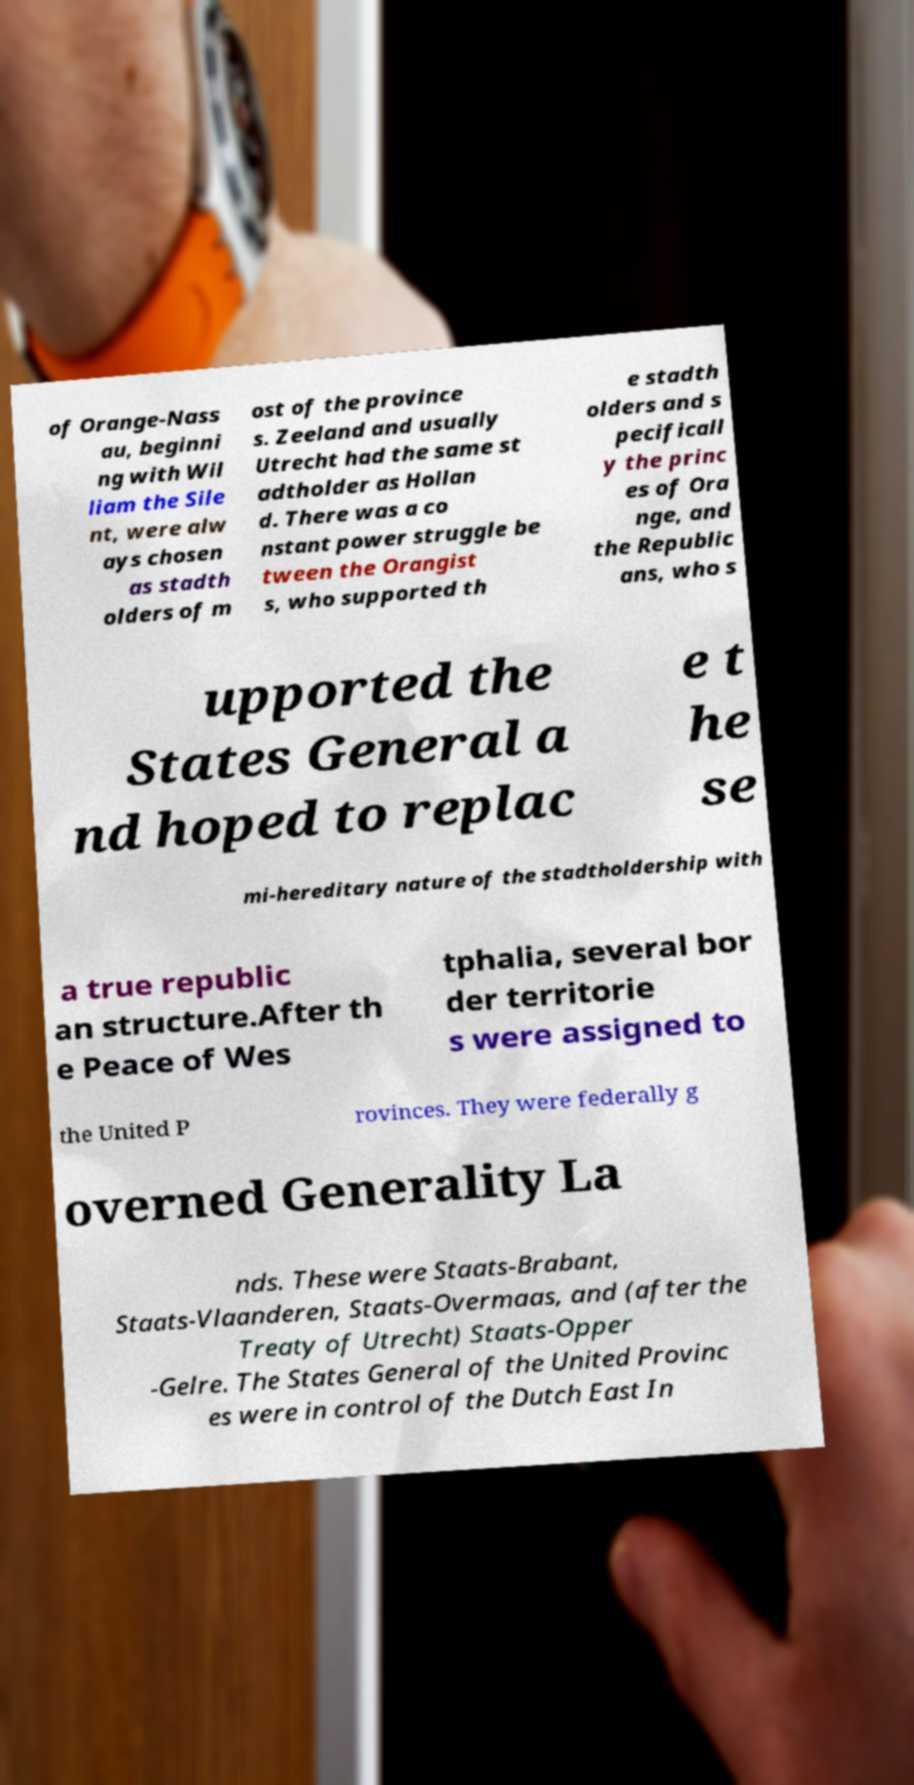Can you read and provide the text displayed in the image?This photo seems to have some interesting text. Can you extract and type it out for me? of Orange-Nass au, beginni ng with Wil liam the Sile nt, were alw ays chosen as stadth olders of m ost of the province s. Zeeland and usually Utrecht had the same st adtholder as Hollan d. There was a co nstant power struggle be tween the Orangist s, who supported th e stadth olders and s pecificall y the princ es of Ora nge, and the Republic ans, who s upported the States General a nd hoped to replac e t he se mi-hereditary nature of the stadtholdership with a true republic an structure.After th e Peace of Wes tphalia, several bor der territorie s were assigned to the United P rovinces. They were federally g overned Generality La nds. These were Staats-Brabant, Staats-Vlaanderen, Staats-Overmaas, and (after the Treaty of Utrecht) Staats-Opper -Gelre. The States General of the United Provinc es were in control of the Dutch East In 